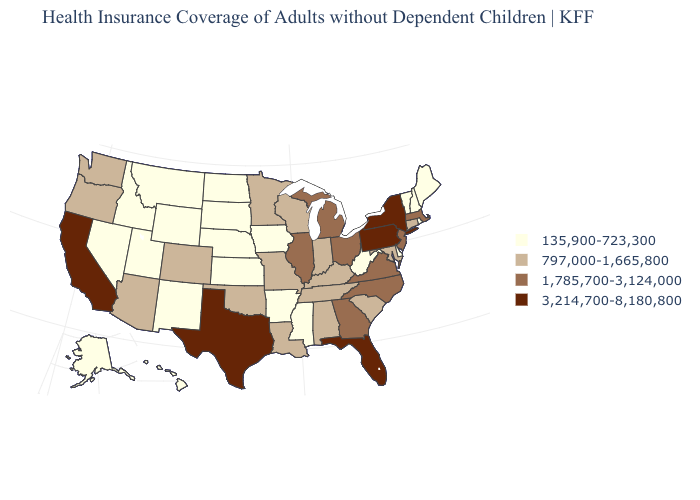What is the highest value in the USA?
Be succinct. 3,214,700-8,180,800. What is the value of Georgia?
Concise answer only. 1,785,700-3,124,000. Name the states that have a value in the range 135,900-723,300?
Answer briefly. Alaska, Arkansas, Delaware, Hawaii, Idaho, Iowa, Kansas, Maine, Mississippi, Montana, Nebraska, Nevada, New Hampshire, New Mexico, North Dakota, Rhode Island, South Dakota, Utah, Vermont, West Virginia, Wyoming. Name the states that have a value in the range 135,900-723,300?
Keep it brief. Alaska, Arkansas, Delaware, Hawaii, Idaho, Iowa, Kansas, Maine, Mississippi, Montana, Nebraska, Nevada, New Hampshire, New Mexico, North Dakota, Rhode Island, South Dakota, Utah, Vermont, West Virginia, Wyoming. What is the highest value in the MidWest ?
Quick response, please. 1,785,700-3,124,000. Name the states that have a value in the range 135,900-723,300?
Give a very brief answer. Alaska, Arkansas, Delaware, Hawaii, Idaho, Iowa, Kansas, Maine, Mississippi, Montana, Nebraska, Nevada, New Hampshire, New Mexico, North Dakota, Rhode Island, South Dakota, Utah, Vermont, West Virginia, Wyoming. Among the states that border Texas , does New Mexico have the highest value?
Concise answer only. No. Is the legend a continuous bar?
Give a very brief answer. No. What is the lowest value in the West?
Be succinct. 135,900-723,300. What is the lowest value in the USA?
Quick response, please. 135,900-723,300. What is the highest value in the MidWest ?
Be succinct. 1,785,700-3,124,000. What is the value of Georgia?
Be succinct. 1,785,700-3,124,000. What is the value of Nevada?
Concise answer only. 135,900-723,300. What is the value of West Virginia?
Be succinct. 135,900-723,300. Does Colorado have a higher value than Montana?
Short answer required. Yes. 